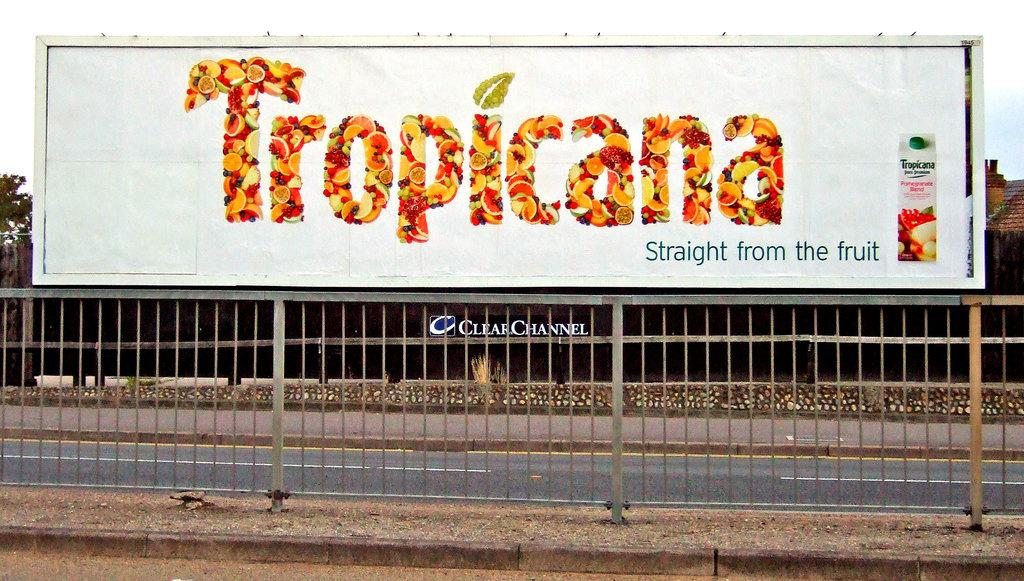<image>
Create a compact narrative representing the image presented. A billboard mounted to a fence advertising Tropicana juice. 